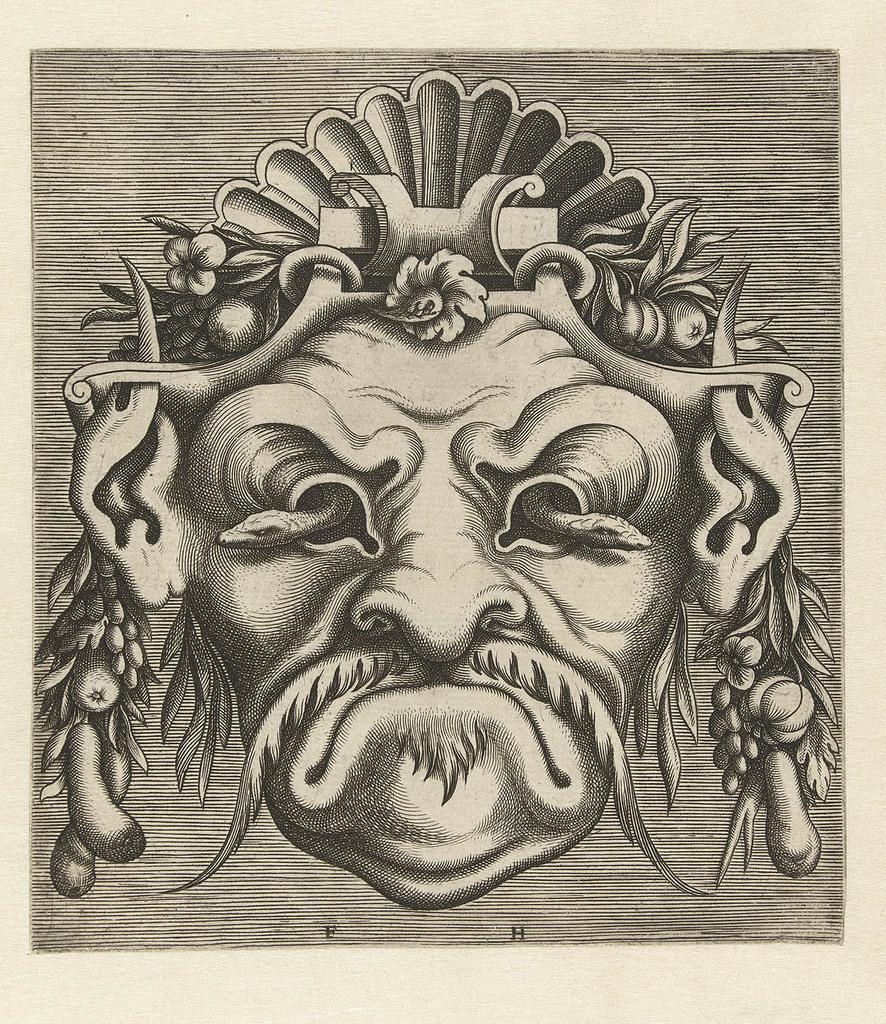Please provide a concise description of this image. Here in this picture we can see a sketch present on a paper. 